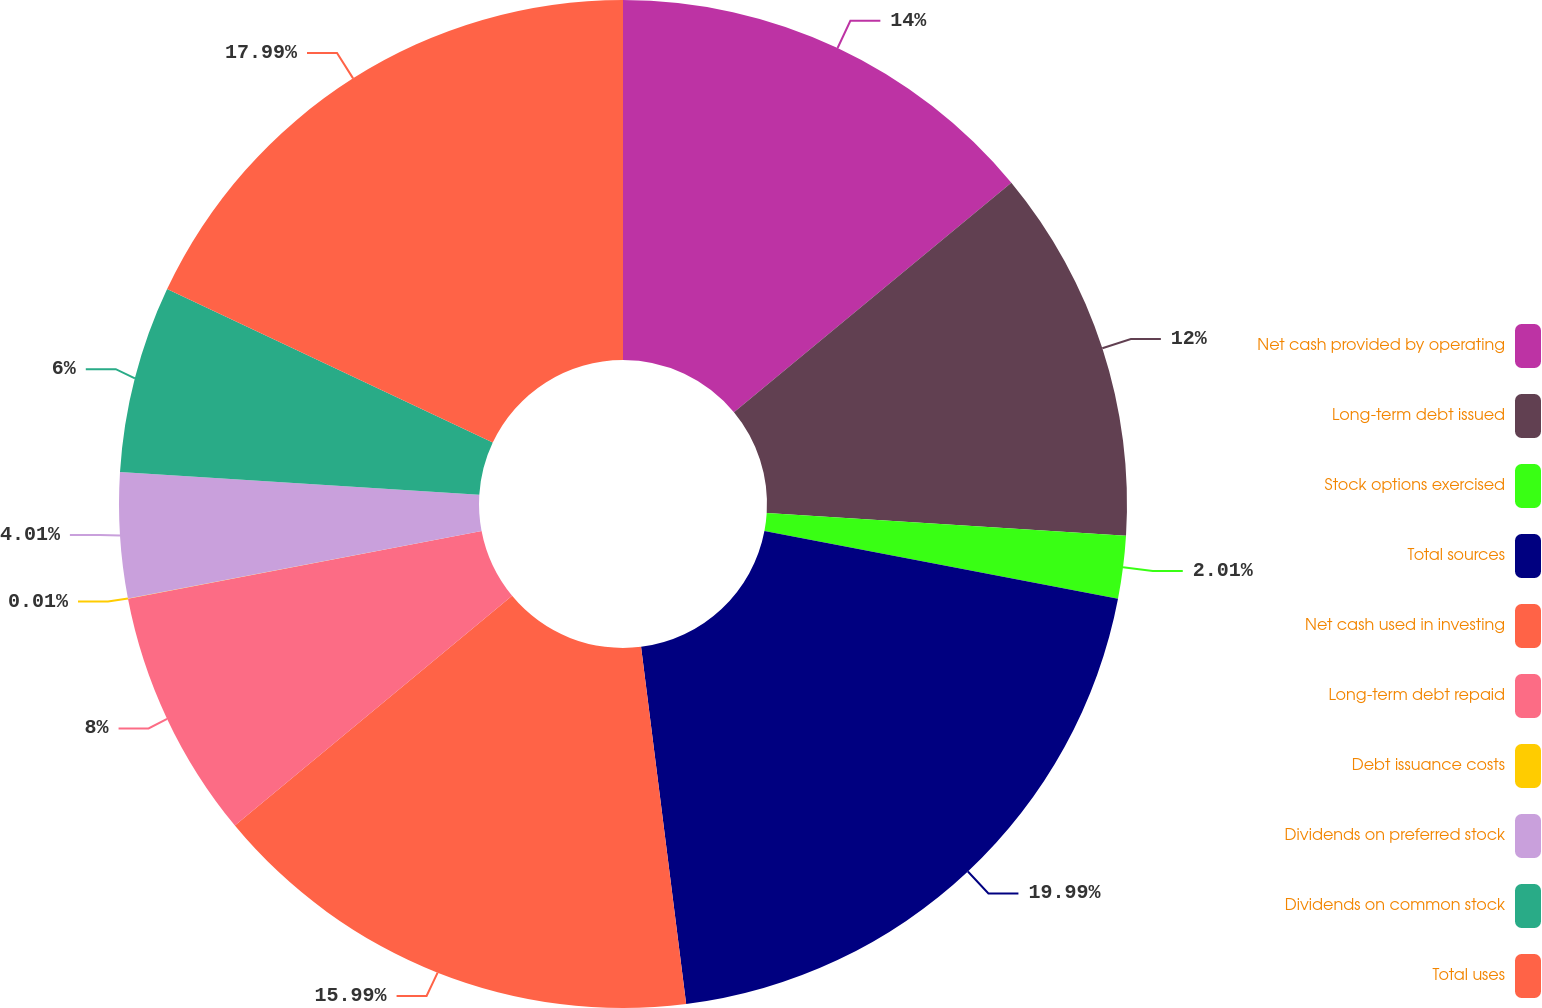Convert chart to OTSL. <chart><loc_0><loc_0><loc_500><loc_500><pie_chart><fcel>Net cash provided by operating<fcel>Long-term debt issued<fcel>Stock options exercised<fcel>Total sources<fcel>Net cash used in investing<fcel>Long-term debt repaid<fcel>Debt issuance costs<fcel>Dividends on preferred stock<fcel>Dividends on common stock<fcel>Total uses<nl><fcel>14.0%<fcel>12.0%<fcel>2.01%<fcel>19.99%<fcel>15.99%<fcel>8.0%<fcel>0.01%<fcel>4.01%<fcel>6.0%<fcel>17.99%<nl></chart> 